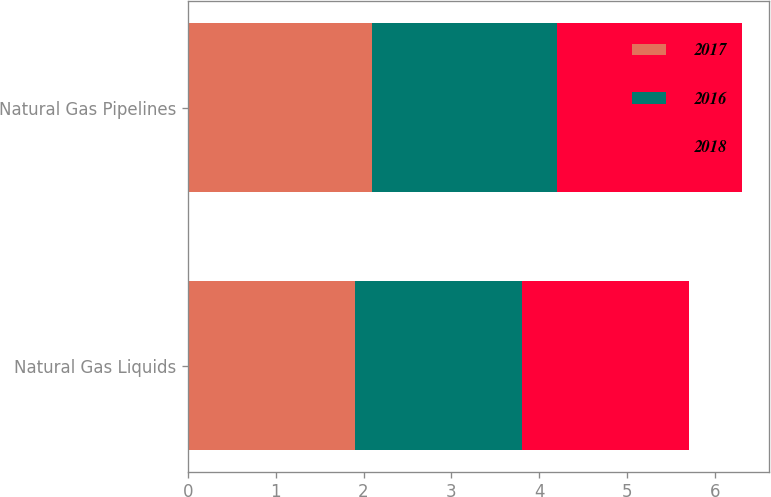Convert chart. <chart><loc_0><loc_0><loc_500><loc_500><stacked_bar_chart><ecel><fcel>Natural Gas Liquids<fcel>Natural Gas Pipelines<nl><fcel>2017<fcel>1.9<fcel>2.1<nl><fcel>2016<fcel>1.9<fcel>2.1<nl><fcel>2018<fcel>1.9<fcel>2.1<nl></chart> 